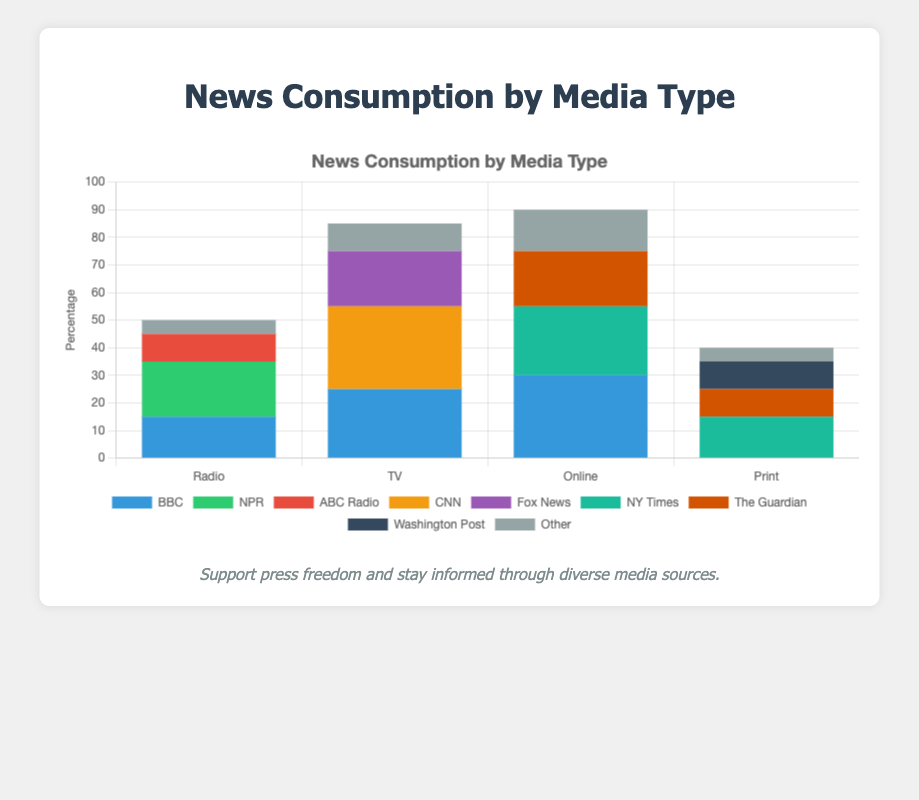Which media source has the highest overall consumption in the figure? Summing up the individual consumptions for each source and comparing them: Radio (15 + 20 + 10 + 5 = 50), TV (25 + 30 + 20 + 10 = 85), Online (30 + 25 + 20 + 15 = 90), Print (10 + 15 + 10 + 5 = 40). Online has the highest overall consumption
Answer: Online Which source has the largest consumption for radio? By looking at the heights of the different segments in the Radio bar, NPR is the tallest segment with a value of 20
Answer: NPR Which media type has the least consumption for BBC? Observing the values for BBC across different media types: Radio (15), TV (25), Online (30), Print (0). Print has the least consumption for BBC
Answer: Print Which news outlet has the highest consumption in the Online media category? From the figure, comparing the segments for Online: BBC (30), NY Times (25), The Guardian (20), Other Online (15). BBC has the highest consumption
Answer: BBC What is the total consumption for Fox News across all media types? Fox News only appears in the TV category with a consumption value of 20, so the total consumption is 20
Answer: 20 How does the consumption of NY Times in Print compare to Online? NY Times has a consumption of 15 in Print and 25 in Online, hence it is 10 less in Print compared to Online
Answer: 10 less What is the combined consumption of 'Other' sources across all media types? Summing the values of 'Other' in each media type: Radio (5), TV (10), Online (15), Print (5). The total is 5 + 10 + 15 + 5 = 35
Answer: 35 Which media type has the most balanced consumption across different news sources? By observing the relative equal heights of the segments within each media type bar, Radio has more evenly distributed segments (15, 20, 10, 5) compared to the other media types
Answer: Radio 